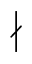Convert formula to latex. <formula><loc_0><loc_0><loc_500><loc_500>\nmid</formula> 